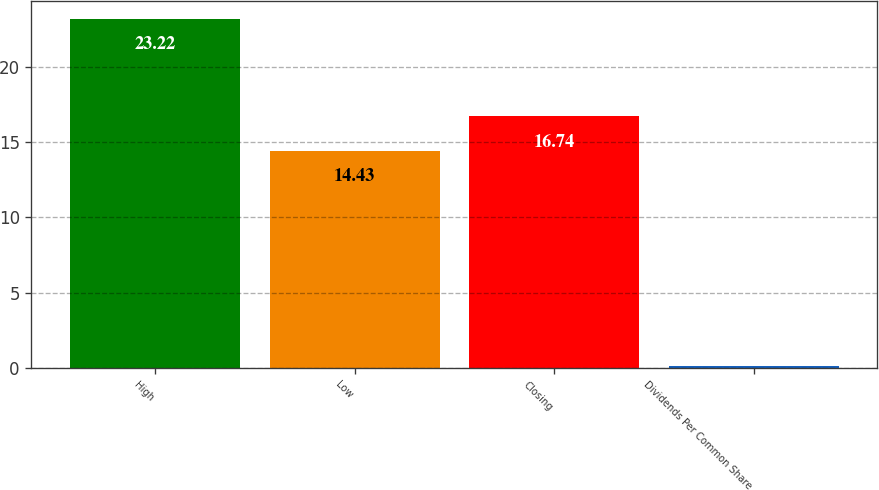Convert chart. <chart><loc_0><loc_0><loc_500><loc_500><bar_chart><fcel>High<fcel>Low<fcel>Closing<fcel>Dividends Per Common Share<nl><fcel>23.22<fcel>14.43<fcel>16.74<fcel>0.14<nl></chart> 